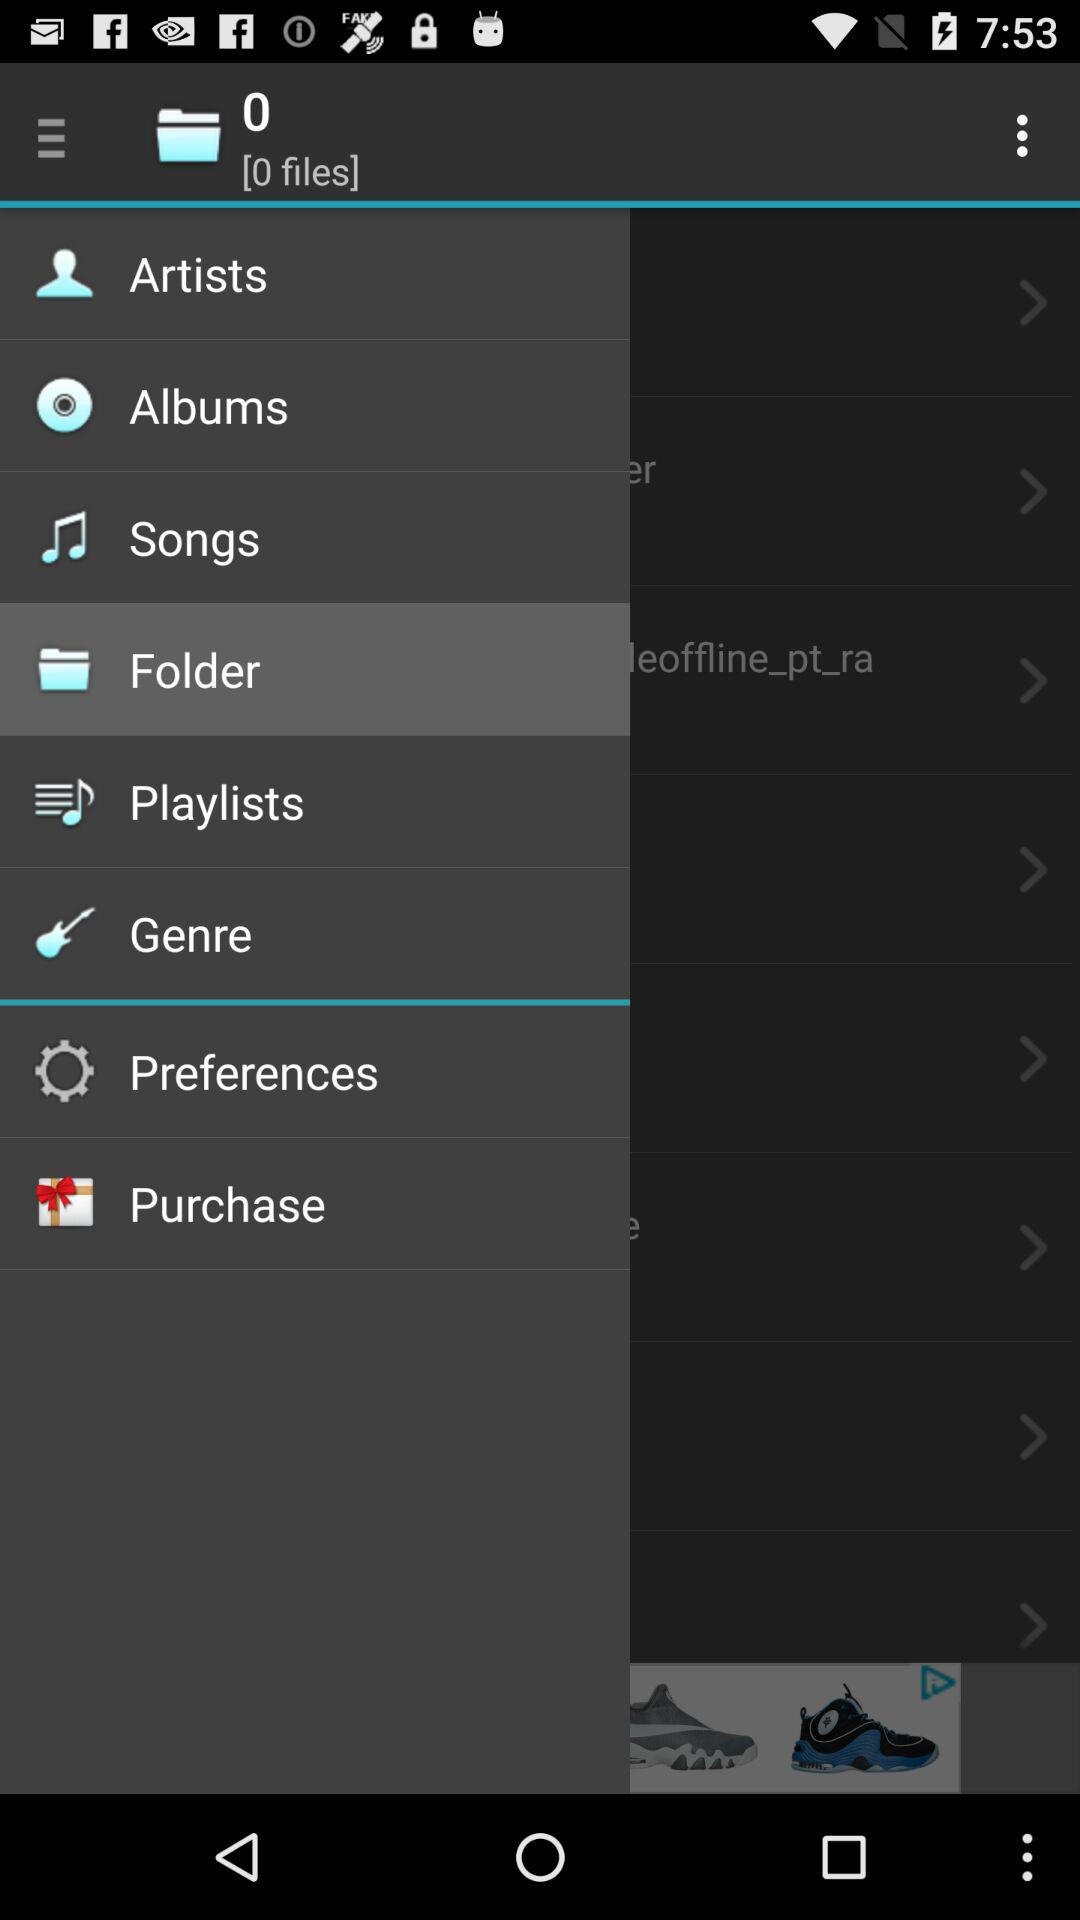What is the given number of files? The given number of files is 0. 